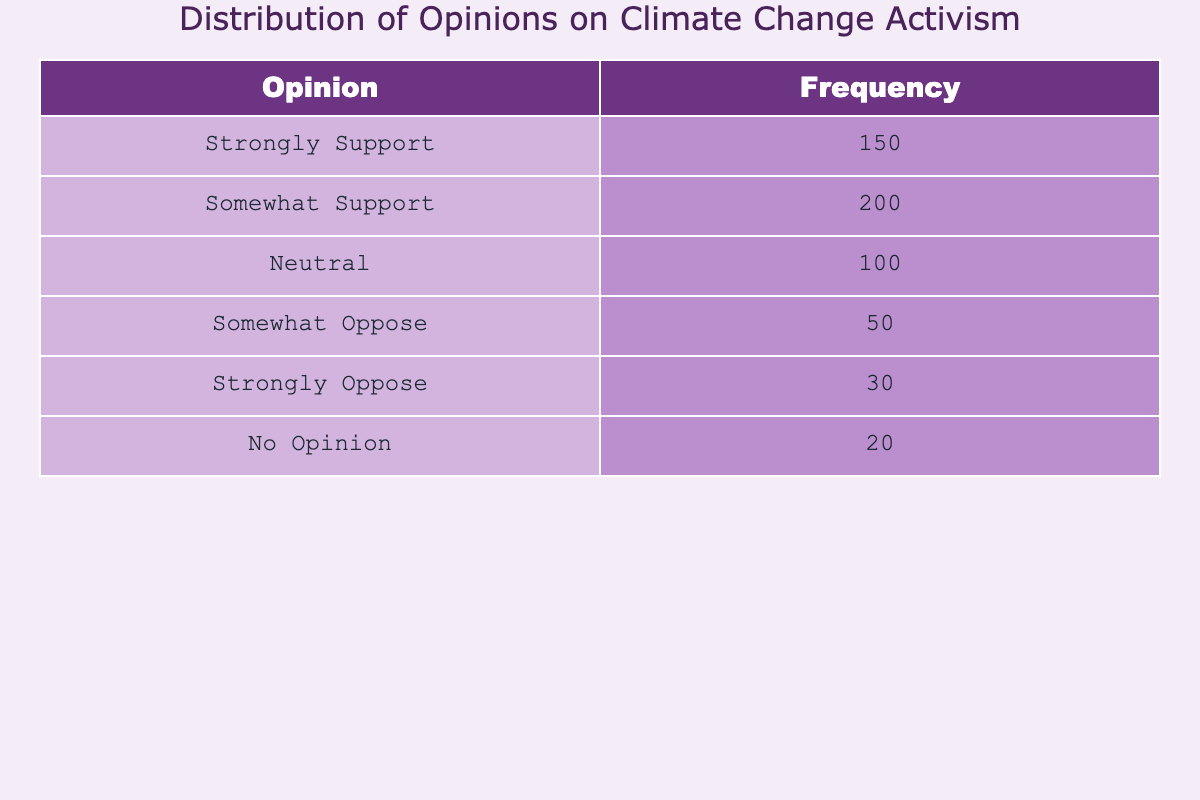What is the total number of youths who are strongly supportive of climate change activism? The table lists the frequency of opinions, and we see that the row for "Strongly Support" has a frequency of 150. This means that 150 youths strongly support climate change activism.
Answer: 150 How many youths have a neutral opinion on climate change activism? By checking the table, we find that the frequency for "Neutral" opinions is 100. Hence, 100 youths feel neutral regarding climate change activism.
Answer: 100 What is the combined frequency of those who oppose climate change activism in any form? To find the total frequency of youths opposing climate change activism, we add the frequencies for "Somewhat Oppose" (50) and "Strongly Oppose" (30). Thus, 50 + 30 = 80.
Answer: 80 Is it true that more youths support climate change activism than those who oppose it? We need to compare the total frequency of supportive opinions (Strongly Support + Somewhat Support) with the total opposing opinions (Somewhat Oppose + Strongly Oppose). Supportive: 150 + 200 = 350. Opposing: 50 + 30 = 80. Since 350 is greater than 80, the statement is true.
Answer: Yes What percentage of youths have no opinion on climate change activism? To calculate the percentage, we take the frequency of "No Opinion" (20) and divide it by the total number of youths (150 + 200 + 100 + 50 + 30 + 20 = 650). Then we multiply by 100 to convert it to a percentage: (20 / 650) * 100 = 3.08%, which can be rounded to two decimal places.
Answer: Approximately 3.08% What is the average frequency of opinions among those who support climate change activism? We will determine the average frequency of supportive opinions which include "Strongly Support" (150) and "Somewhat Support" (200). The total for these is 150 + 200 = 350. Then, we divide this total by the number of supportive categories (2), which gives us an average of 350 / 2 = 175.
Answer: 175 Is there a greater number of youths who do not have an opinion compared to those who somewhat oppose? We compare the frequencies: "No Opinion" has 20, while "Somewhat Oppose" has 50. Since 20 is less than 50, the statement is false.
Answer: No How many youths are considered to be supportive (including all levels of support) compared to those who are indifferent or have no opinion? Supportive includes "Strongly Support" (150) and "Somewhat Support" (200) for a total of 350, while "Neutral" (100) and "No Opinion" (20) sums up to 120. Comparing 350 to 120 indicates that more youths are supportive.
Answer: Yes 